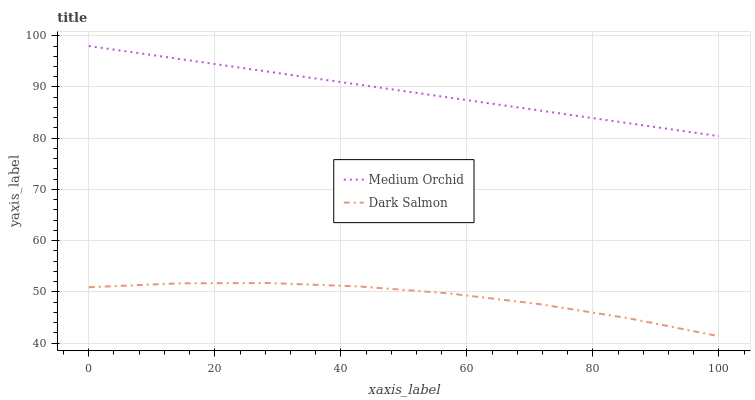Does Dark Salmon have the minimum area under the curve?
Answer yes or no. Yes. Does Medium Orchid have the maximum area under the curve?
Answer yes or no. Yes. Does Dark Salmon have the maximum area under the curve?
Answer yes or no. No. Is Medium Orchid the smoothest?
Answer yes or no. Yes. Is Dark Salmon the roughest?
Answer yes or no. Yes. Is Dark Salmon the smoothest?
Answer yes or no. No. Does Medium Orchid have the highest value?
Answer yes or no. Yes. Does Dark Salmon have the highest value?
Answer yes or no. No. Is Dark Salmon less than Medium Orchid?
Answer yes or no. Yes. Is Medium Orchid greater than Dark Salmon?
Answer yes or no. Yes. Does Dark Salmon intersect Medium Orchid?
Answer yes or no. No. 